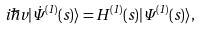<formula> <loc_0><loc_0><loc_500><loc_500>i \hbar { v } | \dot { \Psi } ^ { ( 1 ) } ( s ) \rangle = H ^ { ( 1 ) } ( s ) | \Psi ^ { ( 1 ) } ( s ) \rangle ,</formula> 